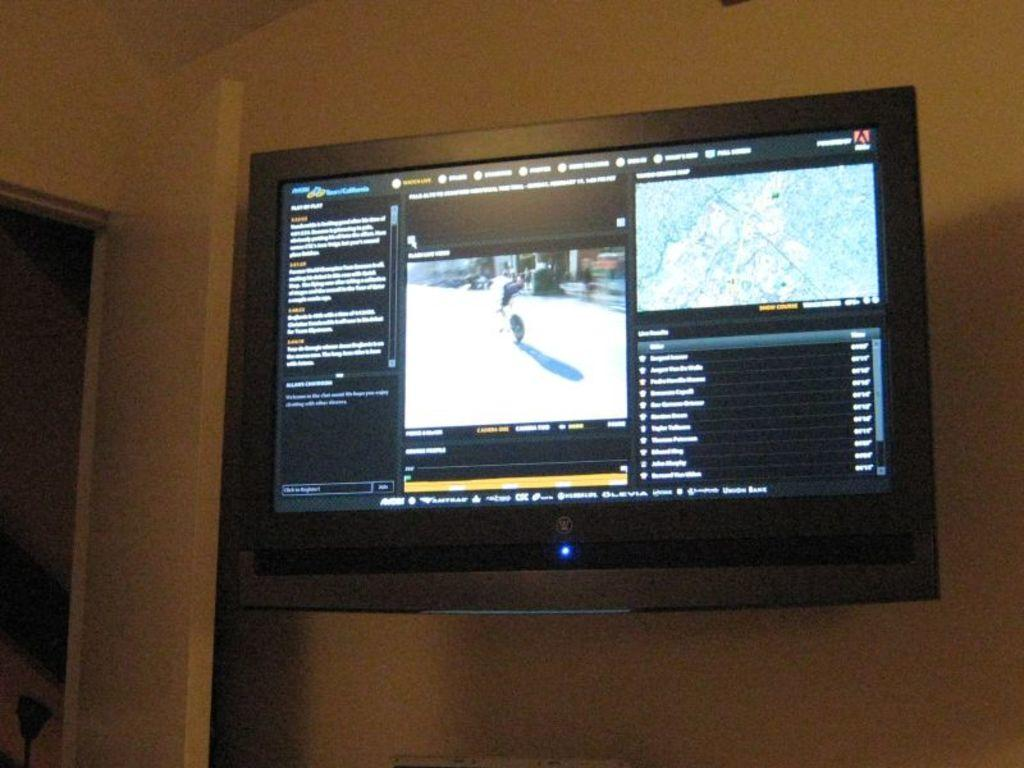What electronic device is mounted on the wall in the image? There is a television on a wall in the image. What feature is present on the left side of the image? There is a door on the left side of the image. How many geese are visible in the image? There are no geese present in the image. What type of waves can be seen in the image? There are no waves present in the image. 